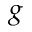<formula> <loc_0><loc_0><loc_500><loc_500>g</formula> 